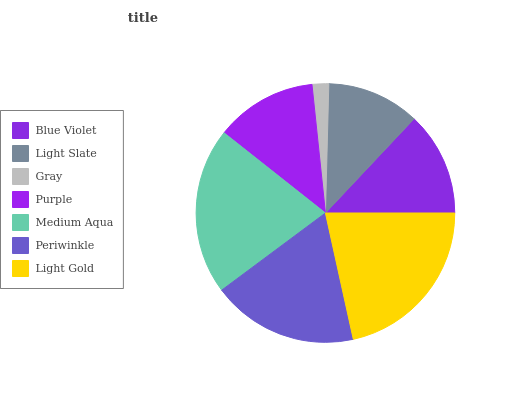Is Gray the minimum?
Answer yes or no. Yes. Is Light Gold the maximum?
Answer yes or no. Yes. Is Light Slate the minimum?
Answer yes or no. No. Is Light Slate the maximum?
Answer yes or no. No. Is Blue Violet greater than Light Slate?
Answer yes or no. Yes. Is Light Slate less than Blue Violet?
Answer yes or no. Yes. Is Light Slate greater than Blue Violet?
Answer yes or no. No. Is Blue Violet less than Light Slate?
Answer yes or no. No. Is Blue Violet the high median?
Answer yes or no. Yes. Is Blue Violet the low median?
Answer yes or no. Yes. Is Light Slate the high median?
Answer yes or no. No. Is Medium Aqua the low median?
Answer yes or no. No. 